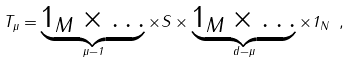Convert formula to latex. <formula><loc_0><loc_0><loc_500><loc_500>T _ { \mu } = \underbrace { 1 _ { M } \times \dots } _ { \mu - 1 } \times S \times \underbrace { 1 _ { M } \times \dots } _ { d - \mu } \times 1 _ { N } \ ,</formula> 